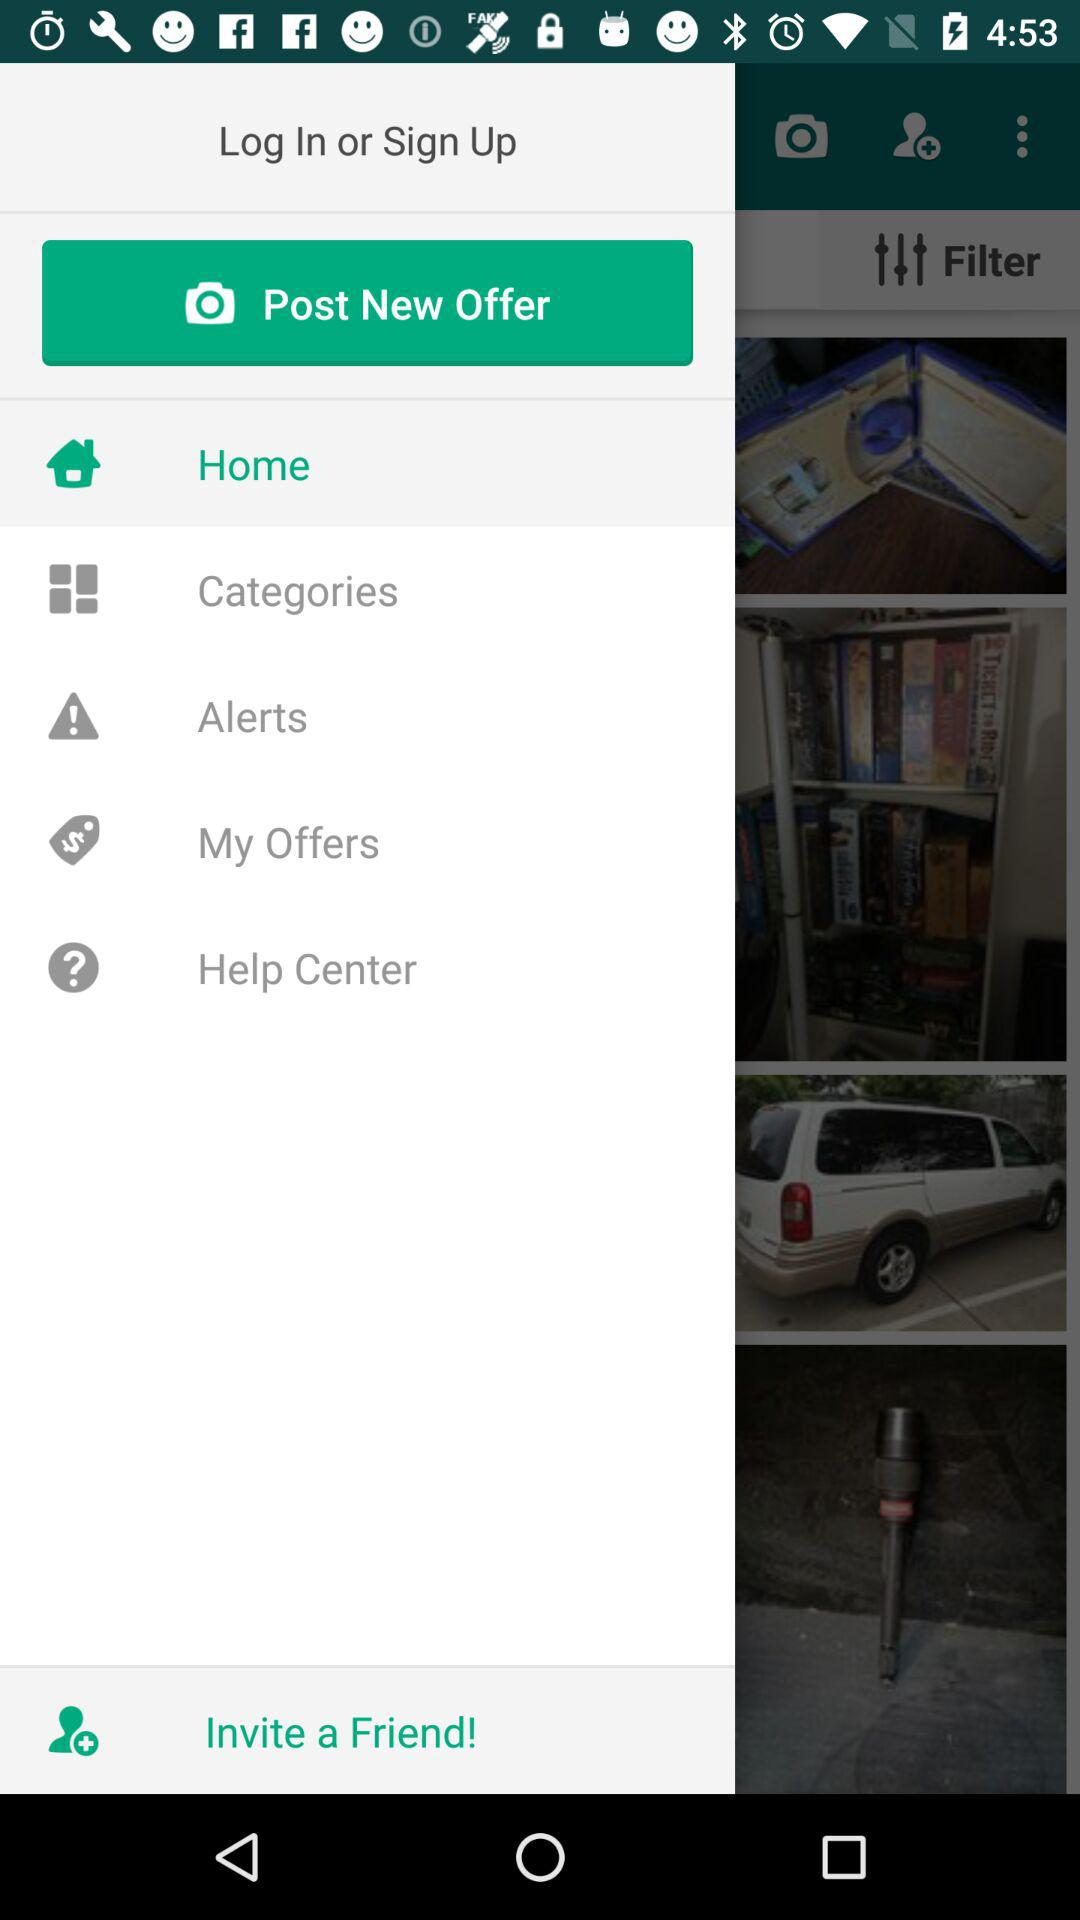Which option is selected? The selected option is "Home". 